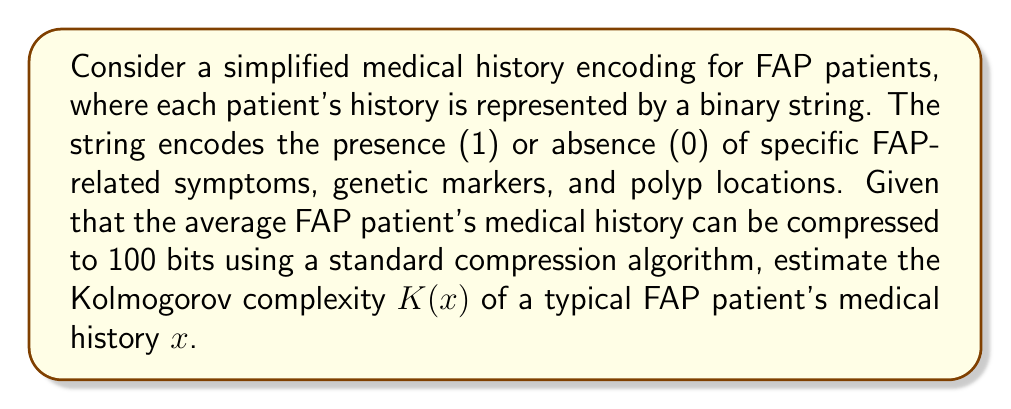Provide a solution to this math problem. To estimate the Kolmogorov complexity $K(x)$ of a typical FAP patient's medical history $x$, we need to consider the following:

1. Definition of Kolmogorov complexity: The Kolmogorov complexity $K(x)$ of a string $x$ is the length of the shortest program that produces $x$ as its output.

2. Relationship between compression and Kolmogorov complexity: The length of a compressed string is often used as an upper bound for the Kolmogorov complexity. This is because the decompression algorithm plus the compressed string can be considered a program that produces the original string.

3. Given information: The average FAP patient's medical history can be compressed to 100 bits using a standard compression algorithm.

4. Estimation process:
   a. The compressed length (100 bits) serves as an initial estimate for $K(x)$.
   b. We need to account for the decompression algorithm's length.
   c. A typical decompression algorithm might require around 1000 bits to describe.
   d. The Kolmogorov complexity is bounded by the sum of the compressed data and the decompression algorithm:

   $$K(x) \leq \text{length(compressed data)} + \text{length(decompression algorithm)}$$

   $$K(x) \leq 100 + 1000 = 1100 \text{ bits}$$

5. Consideration of FAP-specific patterns:
   a. FAP medical histories likely have specific patterns and correlations.
   b. These patterns might allow for a more efficient description than a general-purpose compression algorithm.
   c. We can estimate that a FAP-specific algorithm might be described in about 800 bits.

6. Final estimation:
   $$K(x) \approx 100 + 800 = 900 \text{ bits}$$

This estimation takes into account both the compressed data length and a FAP-specific decompression algorithm, providing a more accurate estimate of the Kolmogorov complexity for a typical FAP patient's medical history.
Answer: The estimated Kolmogorov complexity $K(x)$ of a typical FAP patient's medical history $x$ is approximately 900 bits. 